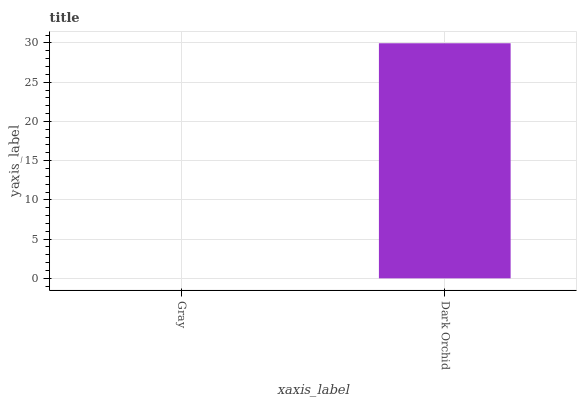Is Gray the minimum?
Answer yes or no. Yes. Is Dark Orchid the maximum?
Answer yes or no. Yes. Is Dark Orchid the minimum?
Answer yes or no. No. Is Dark Orchid greater than Gray?
Answer yes or no. Yes. Is Gray less than Dark Orchid?
Answer yes or no. Yes. Is Gray greater than Dark Orchid?
Answer yes or no. No. Is Dark Orchid less than Gray?
Answer yes or no. No. Is Dark Orchid the high median?
Answer yes or no. Yes. Is Gray the low median?
Answer yes or no. Yes. Is Gray the high median?
Answer yes or no. No. Is Dark Orchid the low median?
Answer yes or no. No. 